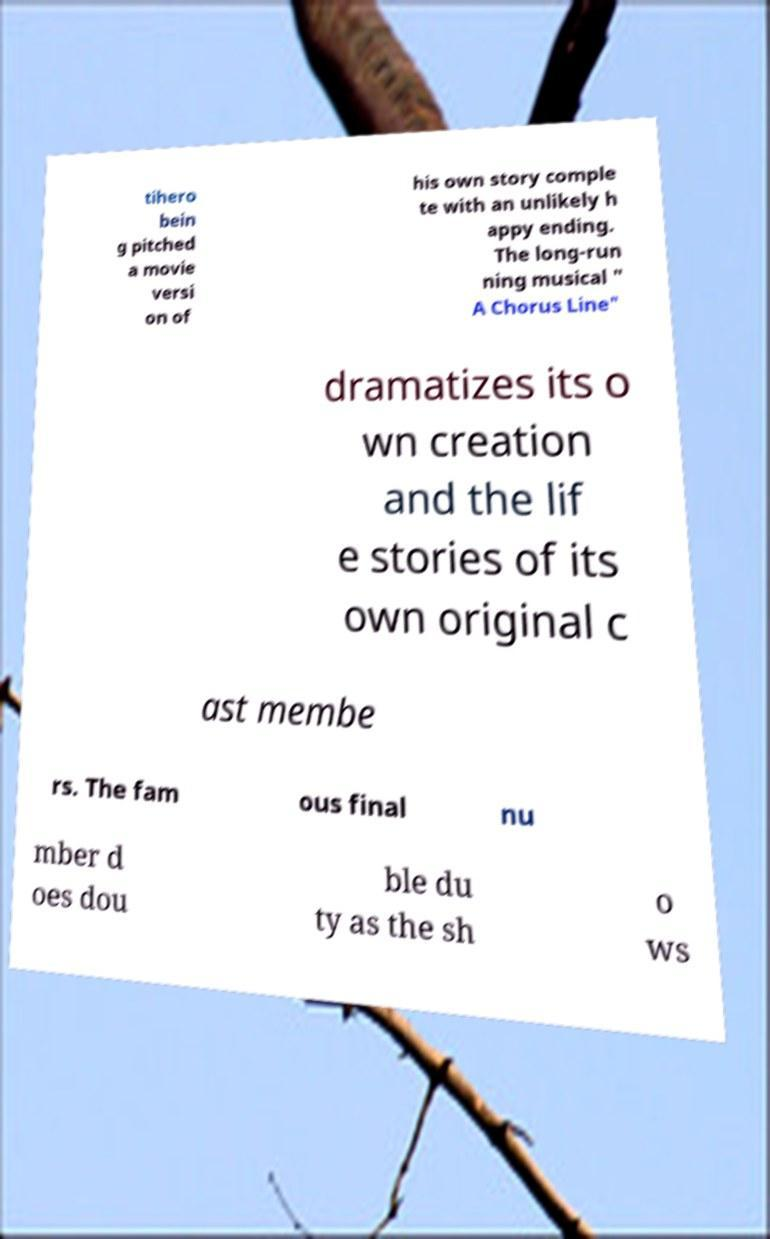There's text embedded in this image that I need extracted. Can you transcribe it verbatim? tihero bein g pitched a movie versi on of his own story comple te with an unlikely h appy ending. The long-run ning musical " A Chorus Line" dramatizes its o wn creation and the lif e stories of its own original c ast membe rs. The fam ous final nu mber d oes dou ble du ty as the sh o ws 